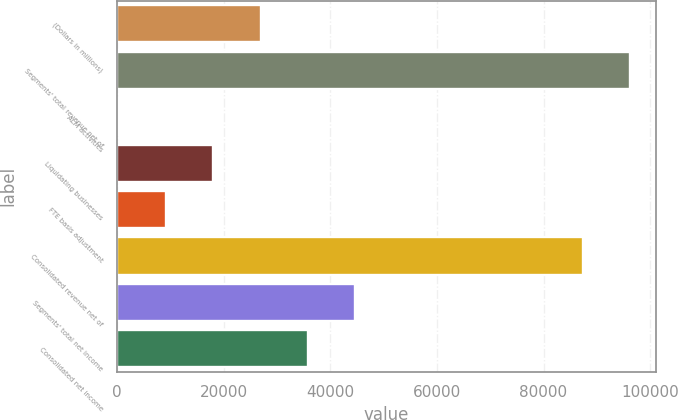Convert chart to OTSL. <chart><loc_0><loc_0><loc_500><loc_500><bar_chart><fcel>(Dollars in millions)<fcel>Segments' total revenue net of<fcel>ALM activities<fcel>Liquidating businesses<fcel>FTE basis adjustment<fcel>Consolidated revenue net of<fcel>Segments' total net income<fcel>Consolidated net income<nl><fcel>26936.7<fcel>96226.9<fcel>312<fcel>18061.8<fcel>9186.9<fcel>87352<fcel>44686.5<fcel>35811.6<nl></chart> 